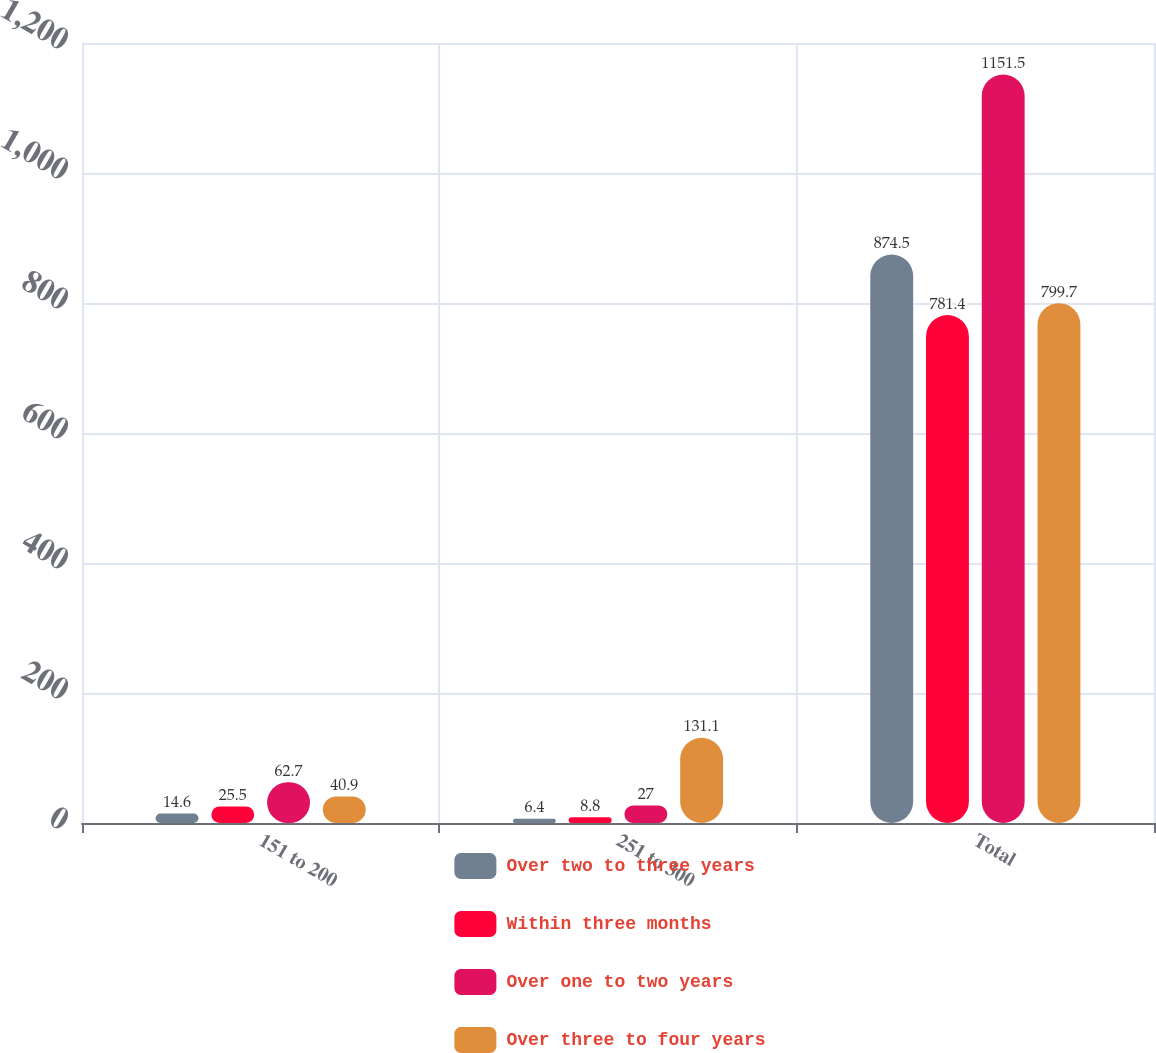<chart> <loc_0><loc_0><loc_500><loc_500><stacked_bar_chart><ecel><fcel>151 to 200<fcel>251 to 300<fcel>Total<nl><fcel>Over two to three years<fcel>14.6<fcel>6.4<fcel>874.5<nl><fcel>Within three months<fcel>25.5<fcel>8.8<fcel>781.4<nl><fcel>Over one to two years<fcel>62.7<fcel>27<fcel>1151.5<nl><fcel>Over three to four years<fcel>40.9<fcel>131.1<fcel>799.7<nl></chart> 